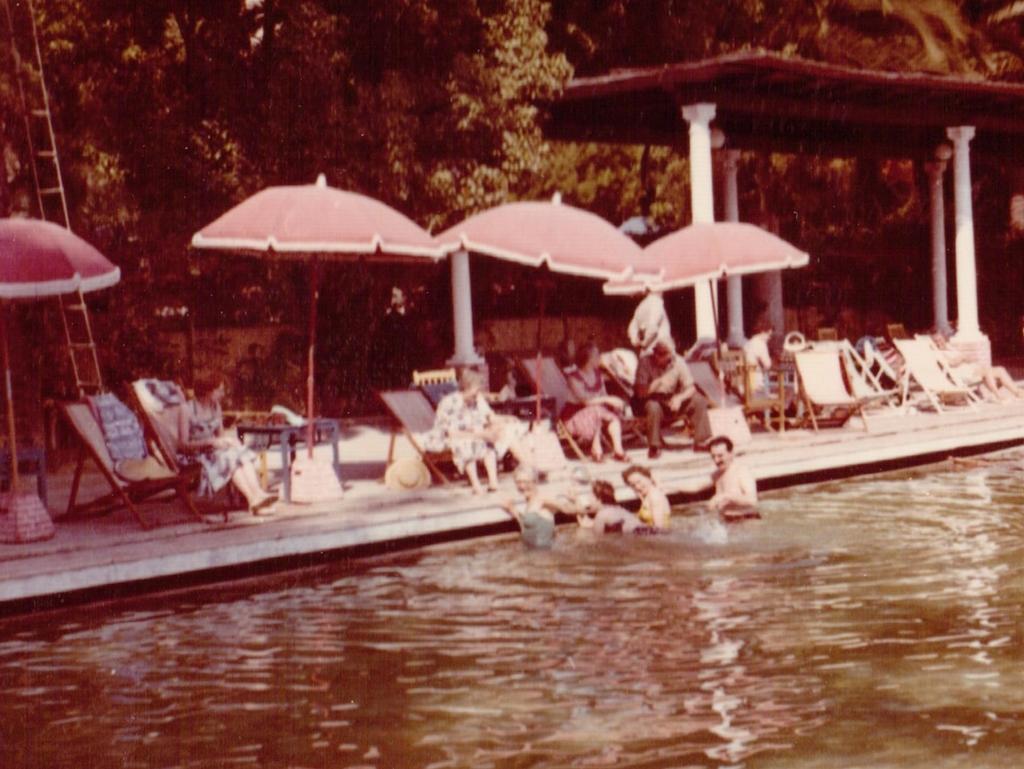Can you describe this image briefly? In this picture we can observe a swimming pool. There are some people in this swimming pool. There are men and women. We can observe umbrellas and chairs hire. We can observe four white color pillars here. In the background there are trees. 